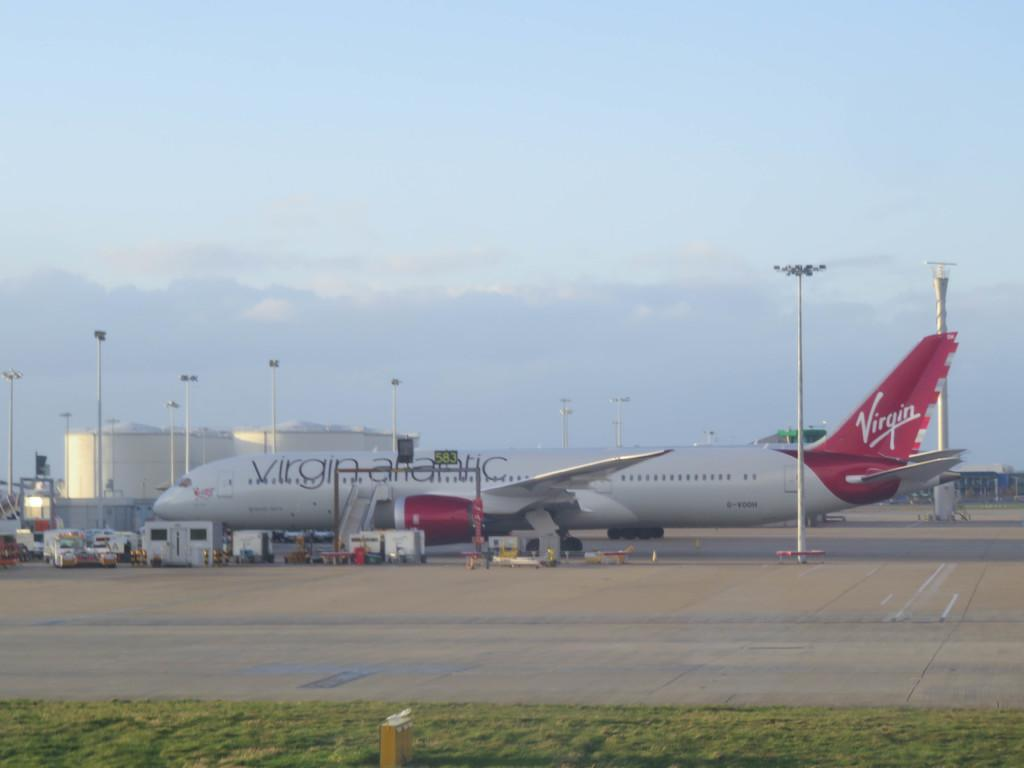<image>
Describe the image concisely. a virgin airlines plane is being loaded at the airport 